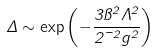<formula> <loc_0><loc_0><loc_500><loc_500>\Delta \sim \exp \left ( - { \frac { 3 \pi ^ { 2 } \Lambda ^ { 2 } } { 2 \mu ^ { 2 } g ^ { 2 } } } \right )</formula> 